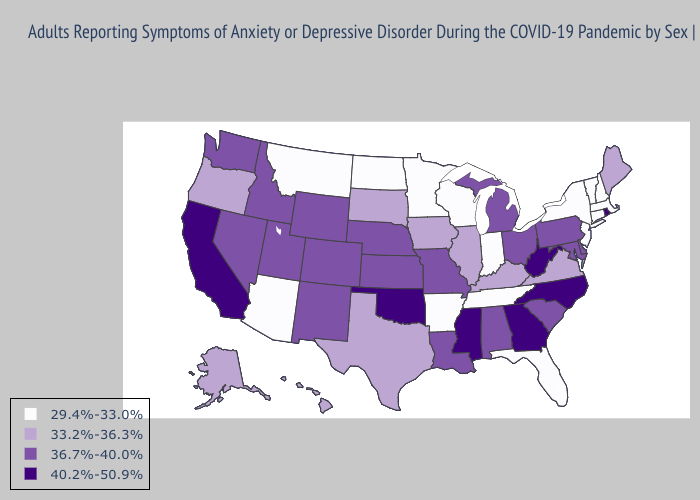Name the states that have a value in the range 40.2%-50.9%?
Short answer required. California, Georgia, Mississippi, North Carolina, Oklahoma, Rhode Island, West Virginia. Does Vermont have a higher value than Nevada?
Concise answer only. No. What is the value of New Mexico?
Keep it brief. 36.7%-40.0%. What is the lowest value in the South?
Answer briefly. 29.4%-33.0%. What is the value of Louisiana?
Give a very brief answer. 36.7%-40.0%. How many symbols are there in the legend?
Write a very short answer. 4. Which states hav the highest value in the South?
Give a very brief answer. Georgia, Mississippi, North Carolina, Oklahoma, West Virginia. Does Utah have a higher value than New Hampshire?
Be succinct. Yes. What is the value of Kansas?
Be succinct. 36.7%-40.0%. What is the highest value in the USA?
Answer briefly. 40.2%-50.9%. What is the value of Wisconsin?
Write a very short answer. 29.4%-33.0%. What is the value of California?
Give a very brief answer. 40.2%-50.9%. Among the states that border Georgia , does Tennessee have the lowest value?
Answer briefly. Yes. Name the states that have a value in the range 29.4%-33.0%?
Keep it brief. Arizona, Arkansas, Connecticut, Florida, Indiana, Massachusetts, Minnesota, Montana, New Hampshire, New Jersey, New York, North Dakota, Tennessee, Vermont, Wisconsin. Name the states that have a value in the range 40.2%-50.9%?
Keep it brief. California, Georgia, Mississippi, North Carolina, Oklahoma, Rhode Island, West Virginia. 